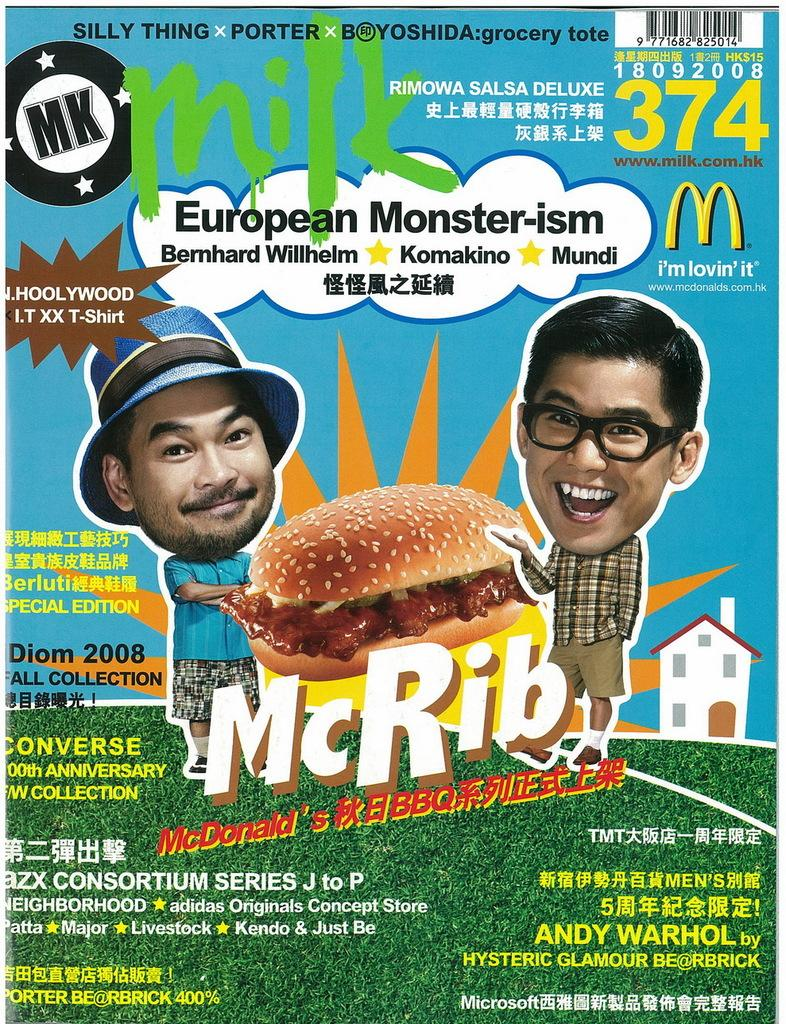What type of visual is the image? The image is a poster. What can be found on the poster besides visual elements? There is text on the poster. Who or what is depicted on the poster? There are two animated persons and a burger shown on the poster. What additional feature can be found on the poster? A bar code is present on the poster. Are there any numbers visible on the poster? Yes, numbers are visible on the poster. Is there a cobweb visible in the image? No, there is no cobweb present in the image. What type of clothing are the animated persons wearing on the poster? The provided facts do not mention any clothing, so we cannot determine the type of clothing the animated persons are wearing. 